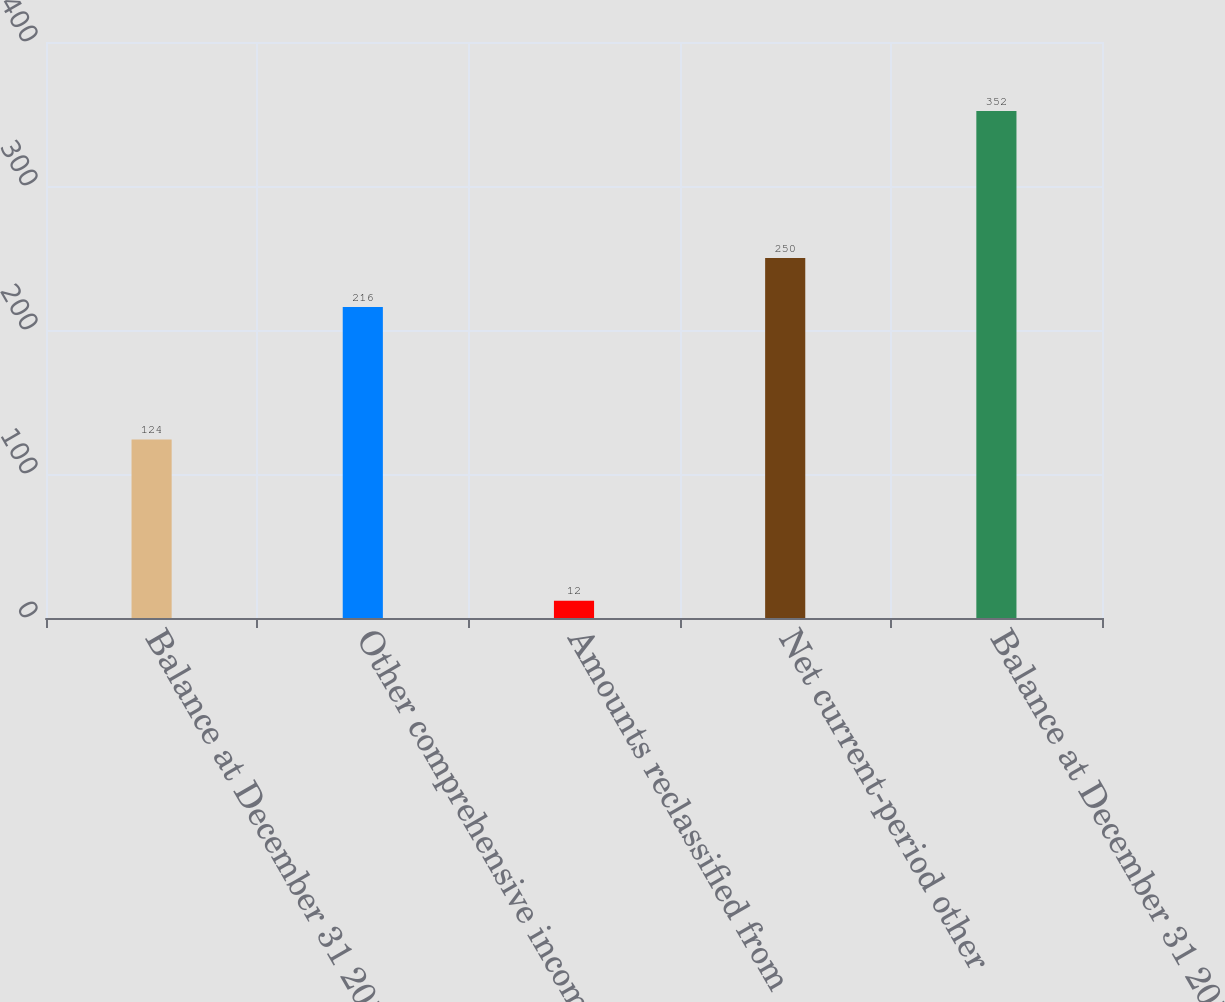<chart> <loc_0><loc_0><loc_500><loc_500><bar_chart><fcel>Balance at December 31 2012<fcel>Other comprehensive income<fcel>Amounts reclassified from<fcel>Net current-period other<fcel>Balance at December 31 2013<nl><fcel>124<fcel>216<fcel>12<fcel>250<fcel>352<nl></chart> 